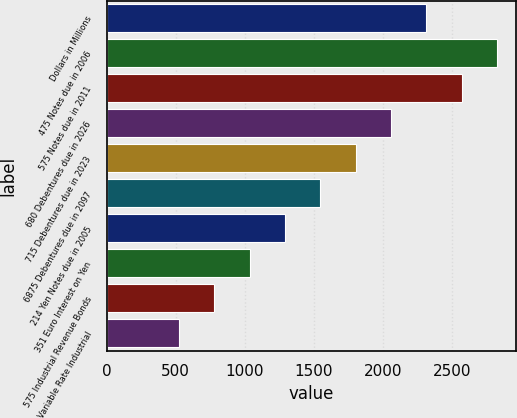<chart> <loc_0><loc_0><loc_500><loc_500><bar_chart><fcel>Dollars in Millions<fcel>475 Notes due in 2006<fcel>575 Notes due in 2011<fcel>680 Debentures due in 2026<fcel>715 Debentures due in 2023<fcel>6875 Debentures due in 2097<fcel>214 Yen Notes due in 2005<fcel>351 Euro Interest on Yen<fcel>575 Industrial Revenue Bonds<fcel>Variable Rate Industrial<nl><fcel>2314.2<fcel>2825.8<fcel>2570<fcel>2058.4<fcel>1802.6<fcel>1546.8<fcel>1291<fcel>1035.2<fcel>779.4<fcel>523.6<nl></chart> 